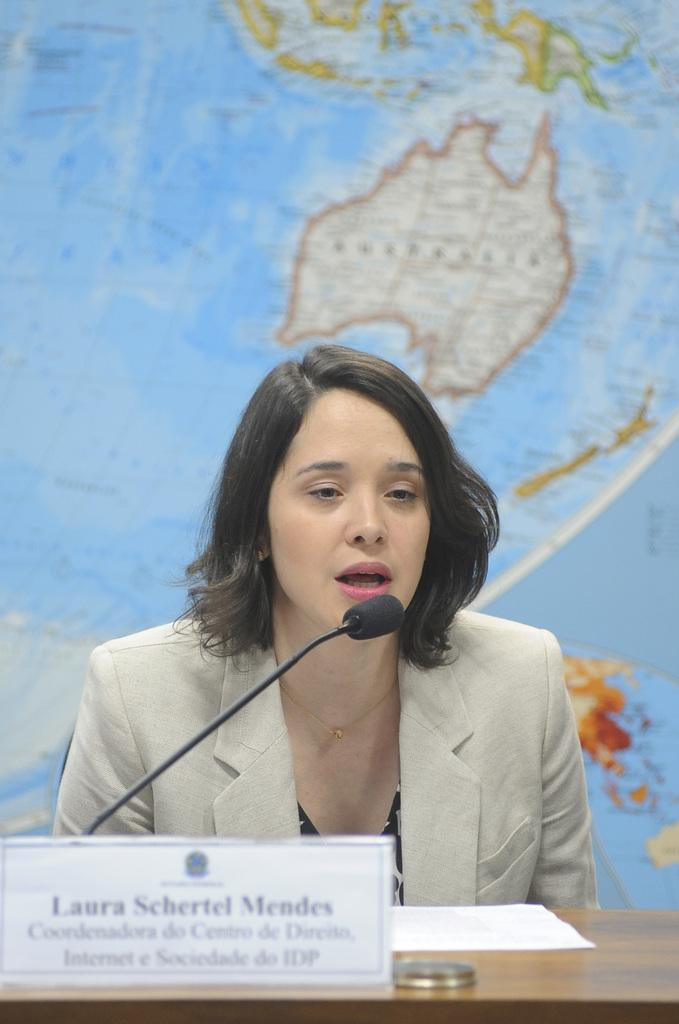What is the person in the image doing? There is a person sitting in the image. What is placed on the table in front of the person? A mic and a name plate are placed on the table in front of the person. What can be seen in the background of the image? There is a map in the background of the image. Can you see any roots growing from the person's feet in the image? There are no roots visible in the image; the person is sitting with their feet on the ground. 